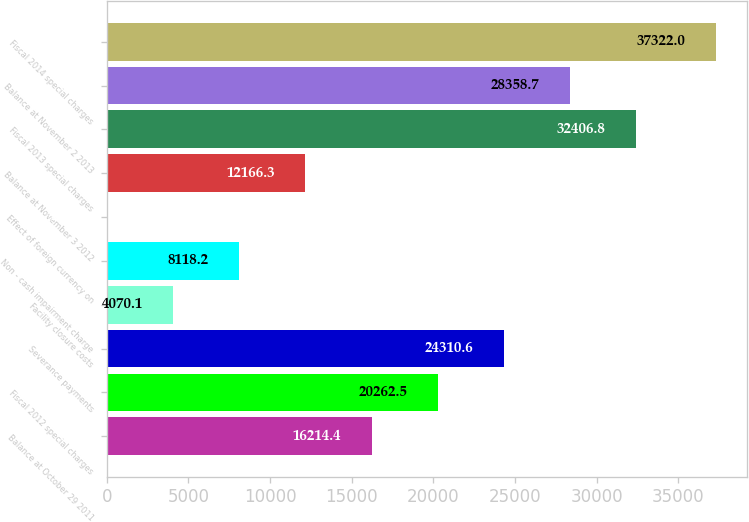Convert chart to OTSL. <chart><loc_0><loc_0><loc_500><loc_500><bar_chart><fcel>Balance at October 29 2011<fcel>Fiscal 2012 special charges<fcel>Severance payments<fcel>Facility closure costs<fcel>Non - cash impairment charge<fcel>Effect of foreign currency on<fcel>Balance at November 3 2012<fcel>Fiscal 2013 special charges<fcel>Balance at November 2 2013<fcel>Fiscal 2014 special charges<nl><fcel>16214.4<fcel>20262.5<fcel>24310.6<fcel>4070.1<fcel>8118.2<fcel>22<fcel>12166.3<fcel>32406.8<fcel>28358.7<fcel>37322<nl></chart> 